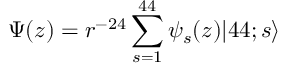Convert formula to latex. <formula><loc_0><loc_0><loc_500><loc_500>\Psi ( z ) = r ^ { - 2 4 } \sum _ { s = 1 } ^ { 4 4 } \psi _ { s } ( z ) | 4 4 ; s \rangle</formula> 